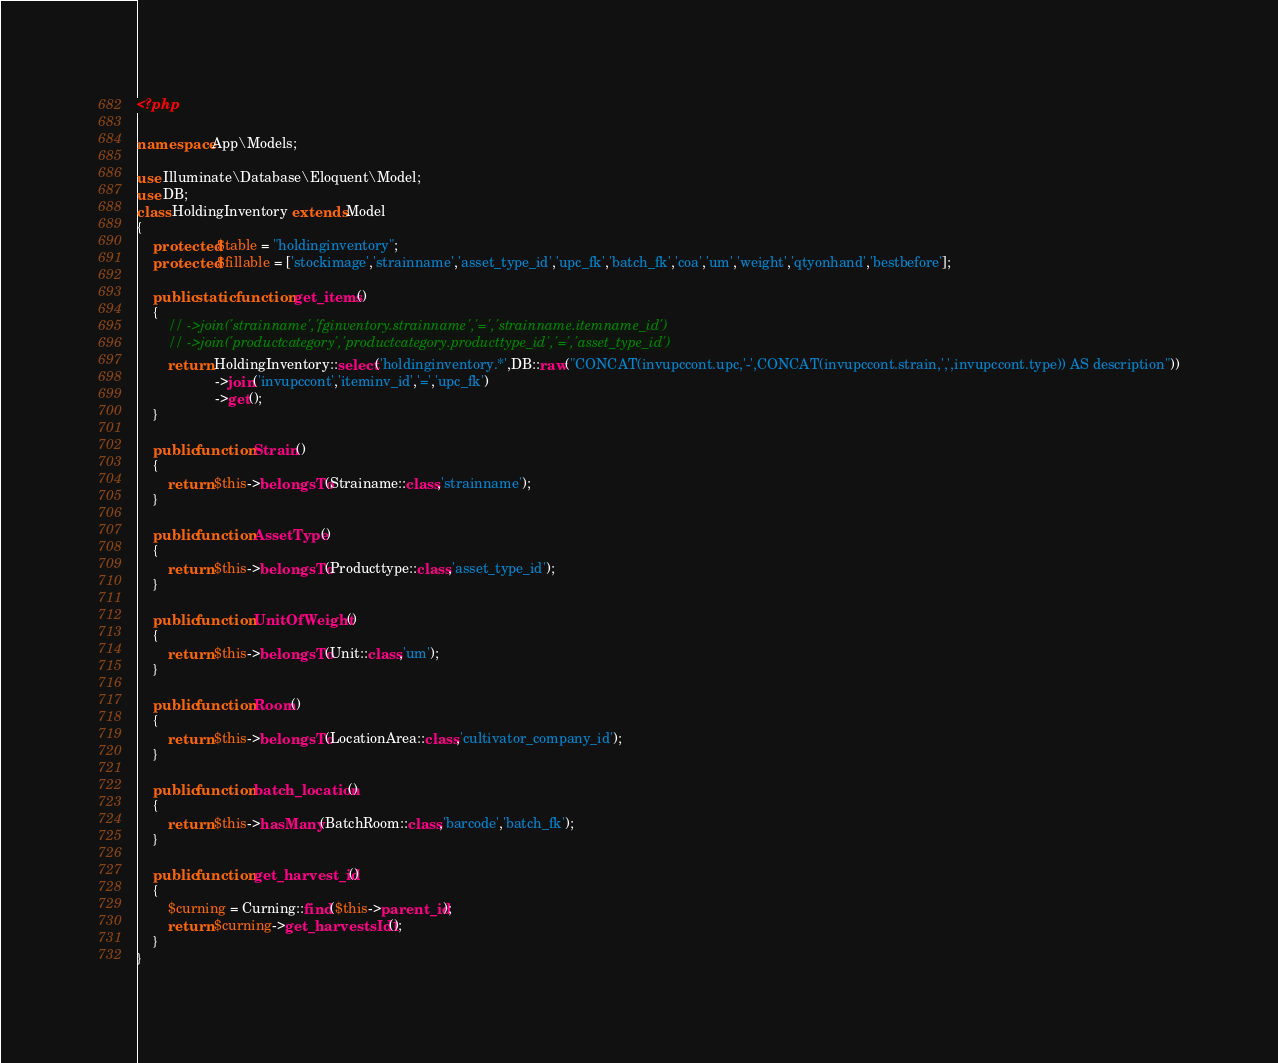Convert code to text. <code><loc_0><loc_0><loc_500><loc_500><_PHP_><?php

namespace App\Models;

use Illuminate\Database\Eloquent\Model;
use DB;
class HoldingInventory extends Model
{
    protected $table = "holdinginventory";
    protected $fillable = ['stockimage','strainname','asset_type_id','upc_fk','batch_fk','coa','um','weight','qtyonhand','bestbefore'];

    public static function get_items()
    {
        // ->join('strainname','fginventory.strainname','=','strainname.itemname_id')
        // ->join('productcategory','productcategory.producttype_id','=','asset_type_id')
        return HoldingInventory::select('holdinginventory.*',DB::raw("CONCAT(invupccont.upc,'-',CONCAT(invupccont.strain,',',invupccont.type)) AS description"))
                    ->join('invupccont','iteminv_id','=','upc_fk')
                    ->get();
    }

    public function Strain()
    {
        return $this->belongsTo(Strainame::class,'strainname');
    }

    public function AssetType()
    {
        return $this->belongsTo(Producttype::class,'asset_type_id');
    }

    public function UnitOfWeight()
    {
        return $this->belongsTo(Unit::class,'um');
    }

    public function Room()
    {
        return $this->belongsTo(LocationArea::class,'cultivator_company_id');
    }

    public function batch_location()
    {
        return $this->hasMany(BatchRoom::class,'barcode','batch_fk');
    }

    public function get_harvest_id()
    {
        $curning = Curning::find($this->parent_id);
        return $curning->get_harvestsId1();
    }
}
</code> 